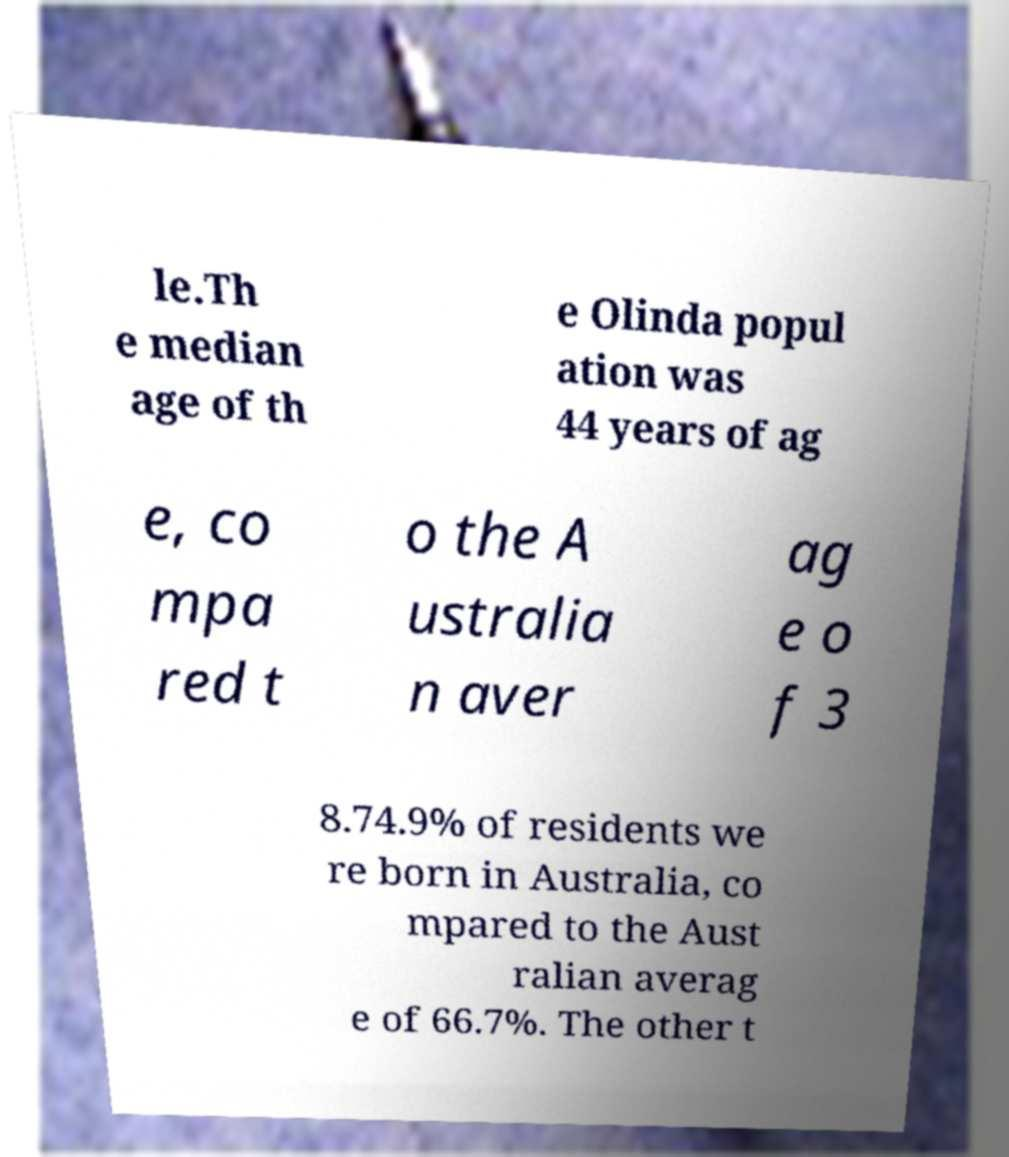Could you extract and type out the text from this image? le.Th e median age of th e Olinda popul ation was 44 years of ag e, co mpa red t o the A ustralia n aver ag e o f 3 8.74.9% of residents we re born in Australia, co mpared to the Aust ralian averag e of 66.7%. The other t 